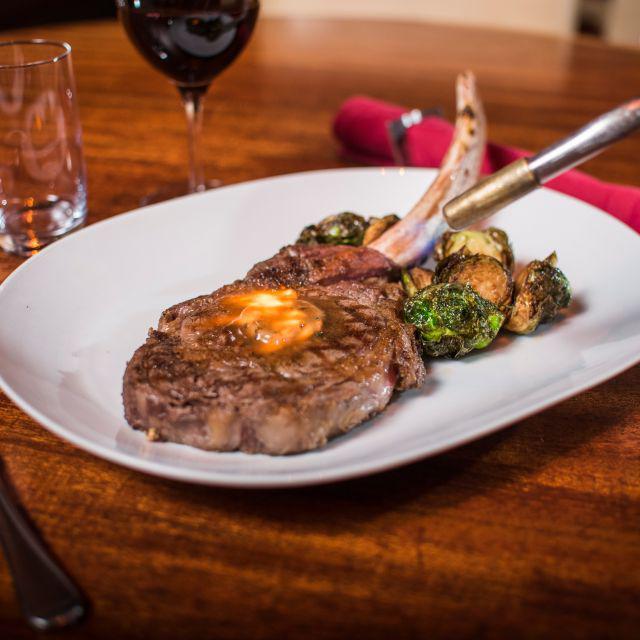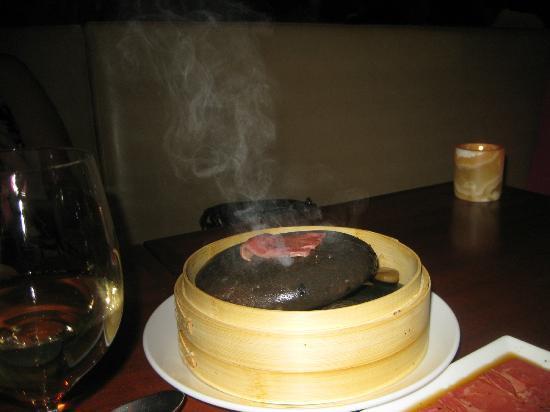The first image is the image on the left, the second image is the image on the right. Examine the images to the left and right. Is the description "there is sliced steak on a white oval plate, there is roasted garlic and greens on the plate and next to the plate is a silver teapot" accurate? Answer yes or no. No. The first image is the image on the left, the second image is the image on the right. Given the left and right images, does the statement "In at least one image there is a bamboo bowl holding hot stones and topped with chopsticks." hold true? Answer yes or no. No. 